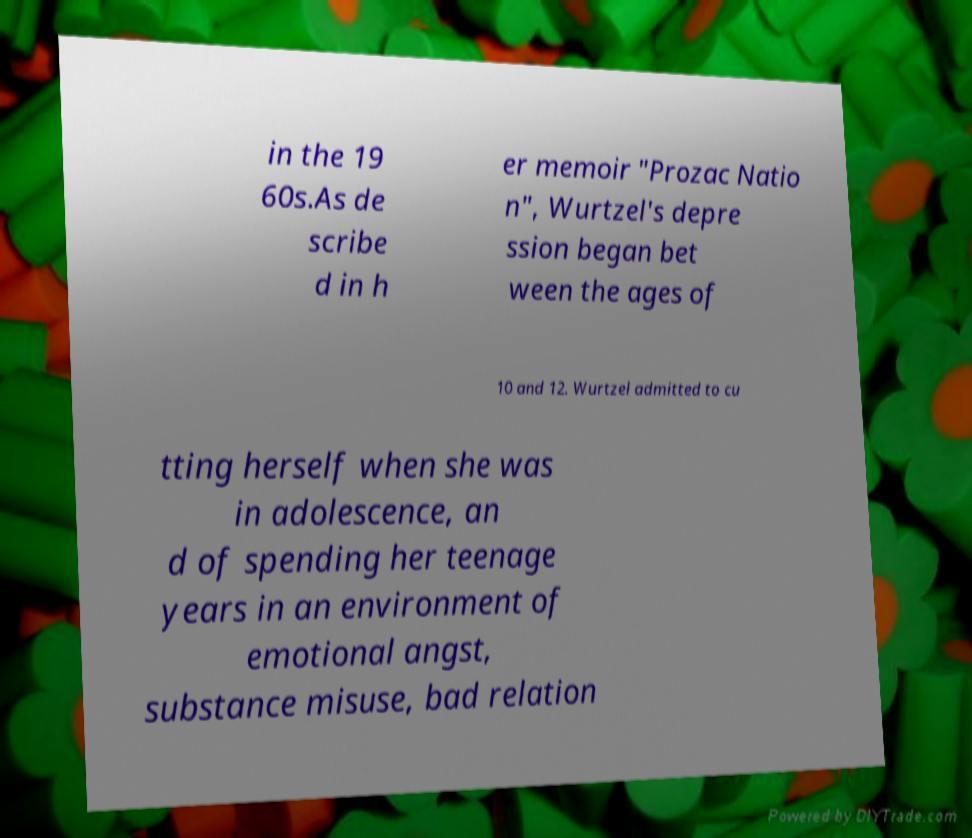Could you extract and type out the text from this image? in the 19 60s.As de scribe d in h er memoir "Prozac Natio n", Wurtzel's depre ssion began bet ween the ages of 10 and 12. Wurtzel admitted to cu tting herself when she was in adolescence, an d of spending her teenage years in an environment of emotional angst, substance misuse, bad relation 